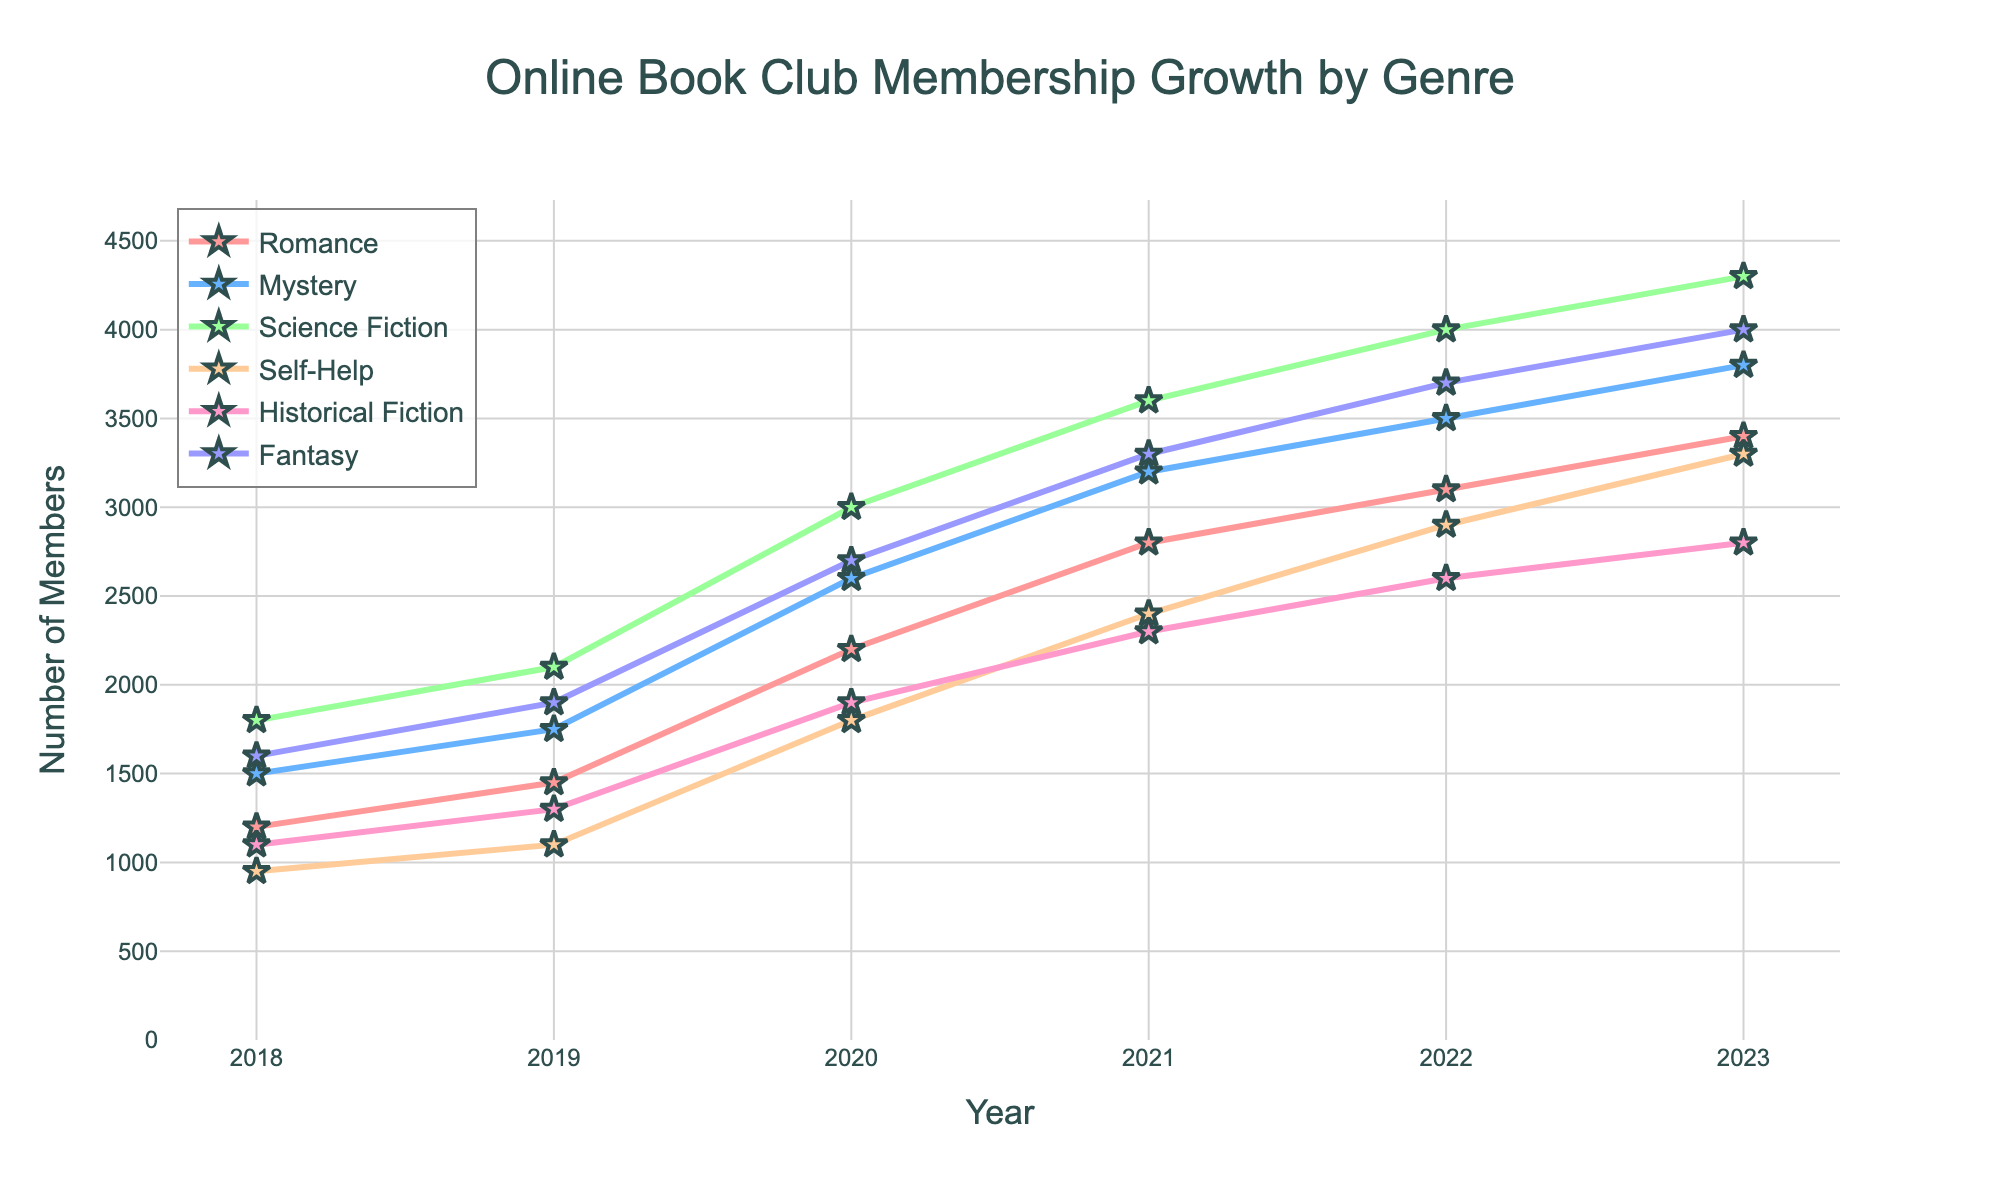Which genre had the highest membership in 2021? Look at the data points for each genre in 2021 and identify the one with the highest value. Fantasy had 3300 members.
Answer: Fantasy Which year saw the highest increase in Science Fiction membership compared to the previous year? Calculate the year-to-year differences for Science Fiction and find the year with the largest increment. The largest difference is between 2019 and 2020 with an increase of 900 members.
Answer: 2020 What is the combined total membership for Romance and Mystery genres in 2023? Add the membership values for Romance and Mystery in 2023. Romance had 3400 and Mystery had 3800 members, so the total is 3400 + 3800 = 7200.
Answer: 7200 Which genre had the steadiest growth in membership from 2018 to 2023? Compare the trends of all genres from 2018 to 2023. The Self-Help genre shows a relatively steady and consistent increase from 950 to 3300 members.
Answer: Self-Help How much did the membership in the Historical Fiction genre increase from 2020 to 2021? Subtract the membership value for Historical Fiction in 2020 from its 2021 value. The difference is 2300 - 1900 = 400.
Answer: 400 Which genre had the lowest starting membership in 2018 and what was the value? Look at the 2018 membership values for all genres and identify the smallest one. Self-Help had 950 members.
Answer: Self-Help, 950 By how much did Fantasy genre memberships exceed the Romance genre in 2022? Subtract the membership value of Romance from that of Fantasy in 2022. Fantasy had 3700 members and Romance had 3100 members. The difference is 3700 - 3100 = 600.
Answer: 600 Which genre saw the first instance where their membership reached or exceeded 3000 members? Identify the first year in which each genre's membership reached or exceeded 3000. Science Fiction first reached 3000 members in 2020.
Answer: Science Fiction In which year did the Mystery genre's membership double compared to its 2018 value? Identify the year when the membership for Mystery became twice its value in 2018 (1500 members). Doubling 1500 gives us 3000. In 2020, it was 2600, and in 2021, it reached 3200. Therefore, 2021 is the first year it doubled.
Answer: 2021 If you sum up the 2023 memberships for all genres, what is the total? Add up the membership values for all genres in 2023. The sum is 3400 (Romance) + 3800 (Mystery) + 4300 (Science Fiction) + 3300 (Self-Help) + 2800 (Historical Fiction) + 4000 (Fantasy) = 21600.
Answer: 21600 